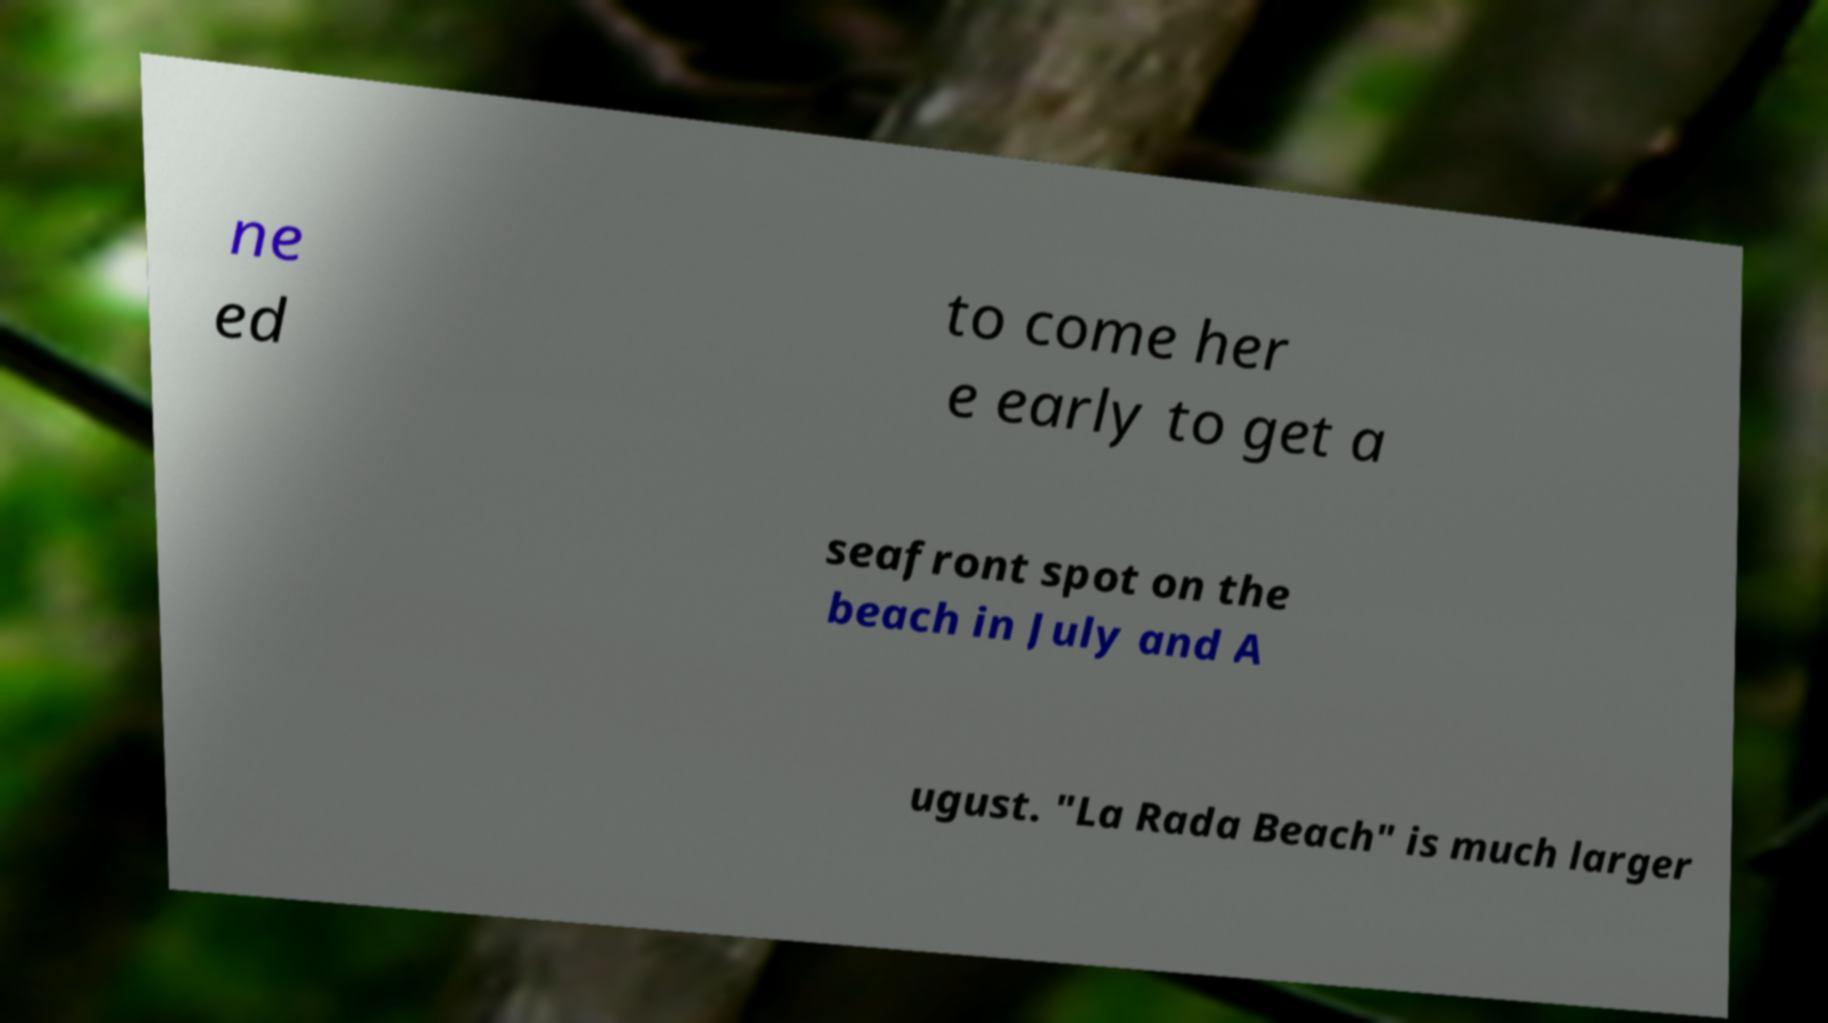I need the written content from this picture converted into text. Can you do that? ne ed to come her e early to get a seafront spot on the beach in July and A ugust. "La Rada Beach" is much larger 